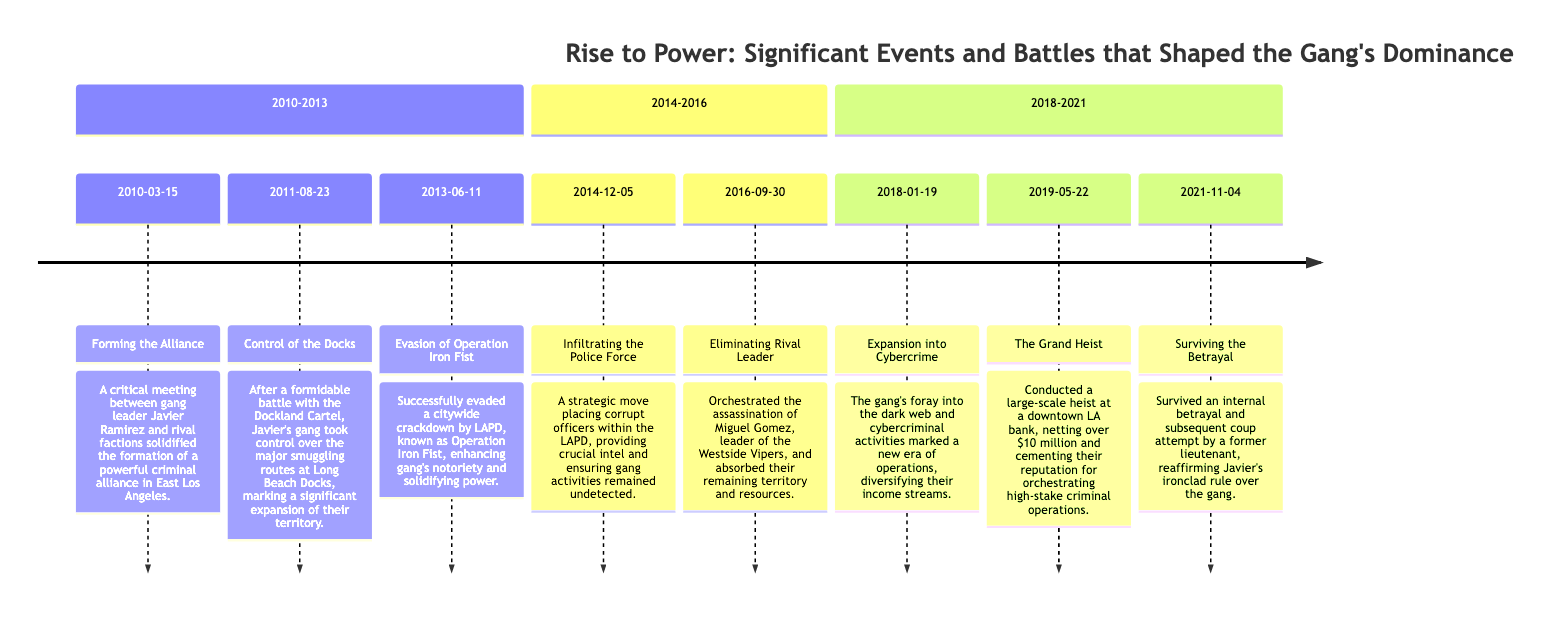What event happened on March 15, 2010? The diagram indicates that on this date, the event "Forming the Alliance" occurred. This is the first recorded event on the timeline and is significant in establishing the criminal alliance.
Answer: Forming the Alliance How many significant events are listed in the timeline? By counting the events in each section of the timeline, there are a total of eight events listed. This count includes all events from the beginning to the last date mentioned.
Answer: 8 What was the outcome of the 'Control of the Docks' event? The diagram details that the outcome of this event on August 23, 2011, was that Javier's gang took control over the major smuggling routes. This indicates a successful expansion of territory.
Answer: Control over smuggling routes Which event followed the 'Evasion of Operation Iron Fist'? The hierarchy of events shows that after 'Evasion of Operation Iron Fist' on June 11, 2013, the next event was 'Infiltrating the Police Force' on December 5, 2014. This includes both events in chronological order.
Answer: Infiltrating the Police Force What was the key action taken on September 30, 2016? According to the timeline, the significant action on this date was "Eliminating Rival Leader," indicating a strategic move by Javier Ramirez to strengthen his gang's dominance by removing a rival.
Answer: Eliminating Rival Leader In what year did the gang expand into cybercrime? The diagram specifies that the expansion into cybercrime occurred on January 19, 2018, marking a crucial diversification in the gang's criminal operations.
Answer: 2018 How did the gang respond to the betrayal in 2021? The timeline states that following the betrayal attempt on November 4, 2021, the gang survived this internal coup attempt, which solidified Javier's control.
Answer: Survived the betrayal What major heist took place in May 2019? The diagram notes that a large-scale heist occurred on May 22, 2019, referred to as 'The Grand Heist,' resulting in a substantial financial gain for the gang.
Answer: The Grand Heist 